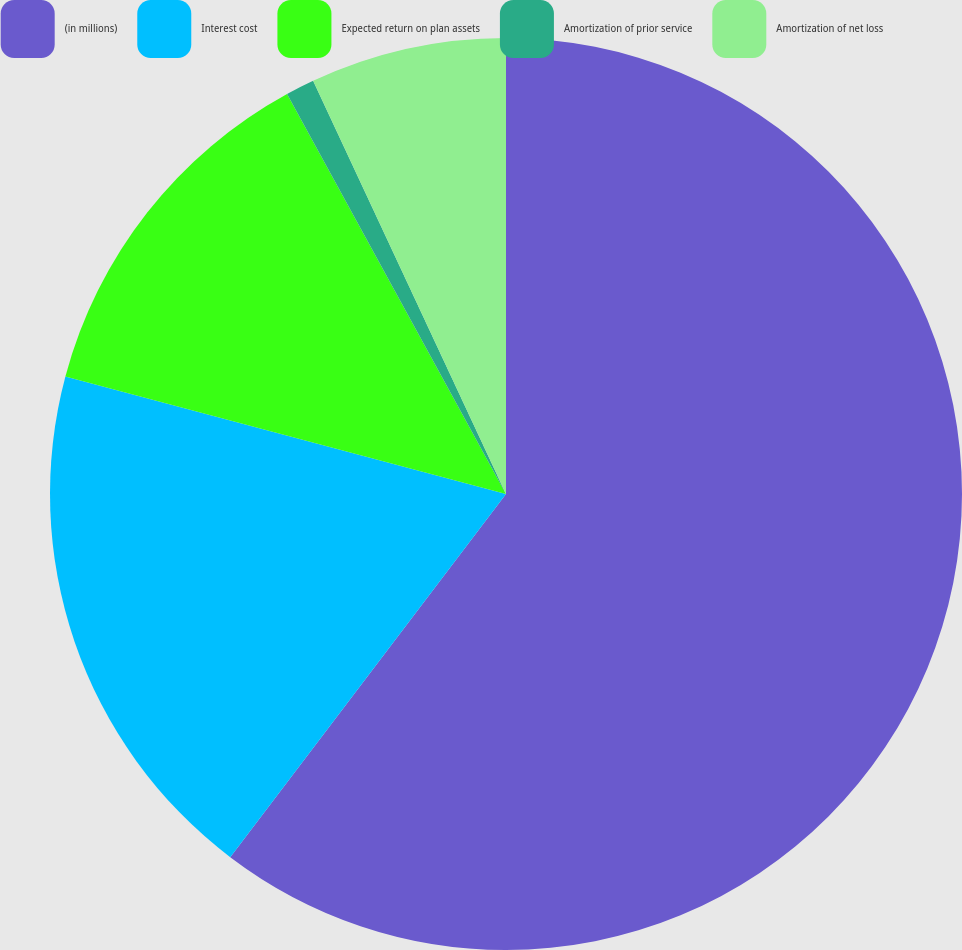Convert chart. <chart><loc_0><loc_0><loc_500><loc_500><pie_chart><fcel>(in millions)<fcel>Interest cost<fcel>Expected return on plan assets<fcel>Amortization of prior service<fcel>Amortization of net loss<nl><fcel>60.33%<fcel>18.81%<fcel>12.88%<fcel>1.02%<fcel>6.95%<nl></chart> 